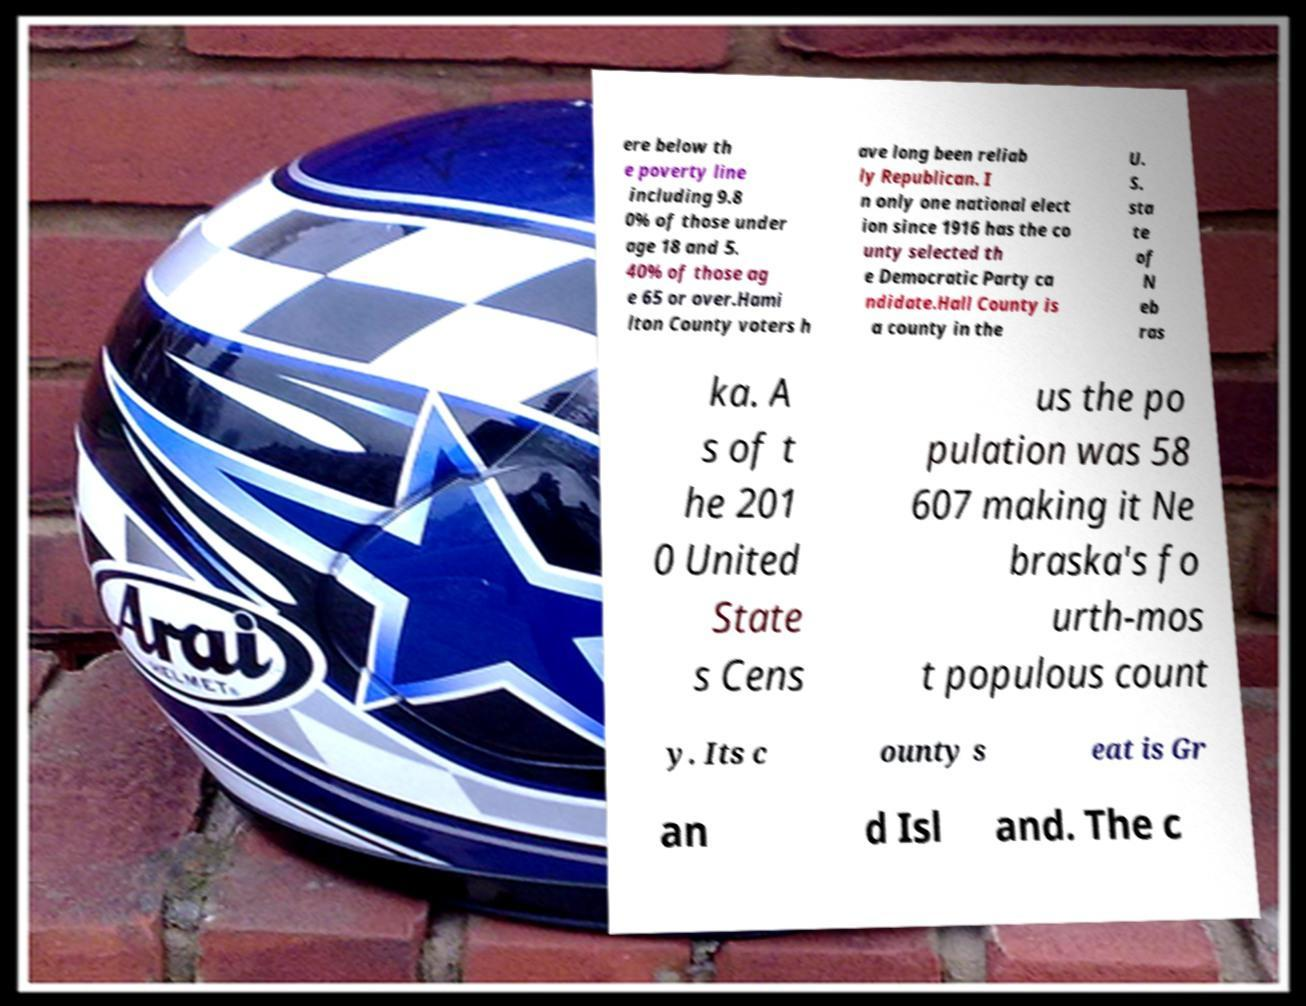Could you extract and type out the text from this image? ere below th e poverty line including 9.8 0% of those under age 18 and 5. 40% of those ag e 65 or over.Hami lton County voters h ave long been reliab ly Republican. I n only one national elect ion since 1916 has the co unty selected th e Democratic Party ca ndidate.Hall County is a county in the U. S. sta te of N eb ras ka. A s of t he 201 0 United State s Cens us the po pulation was 58 607 making it Ne braska's fo urth-mos t populous count y. Its c ounty s eat is Gr an d Isl and. The c 